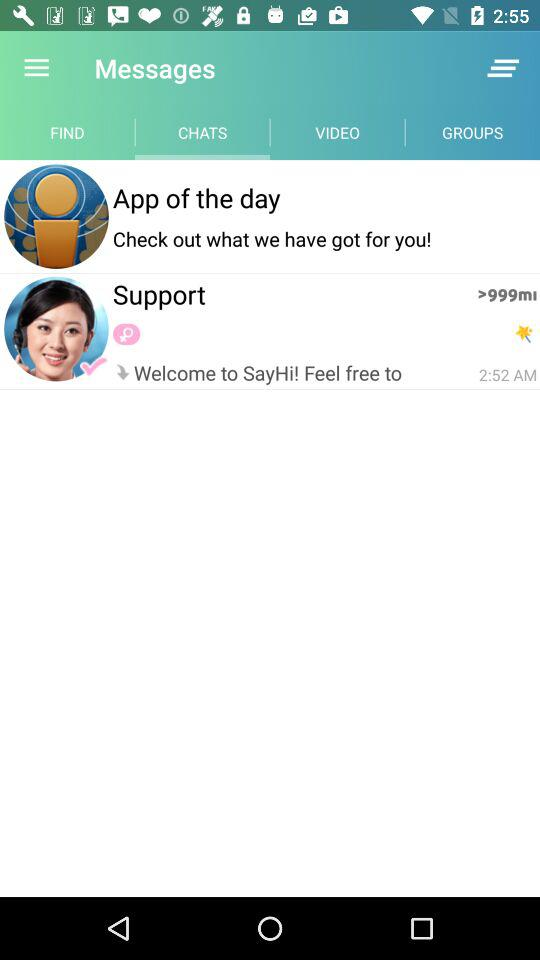Which tab is selected? The selected tab is "CHATS". 